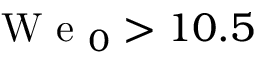Convert formula to latex. <formula><loc_0><loc_0><loc_500><loc_500>W e _ { 0 } > 1 0 . 5</formula> 